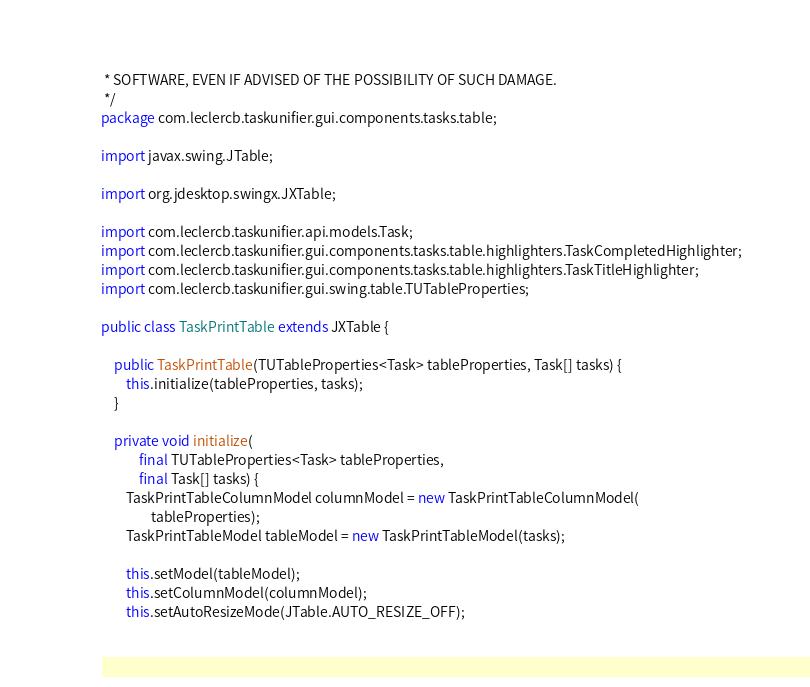<code> <loc_0><loc_0><loc_500><loc_500><_Java_> * SOFTWARE, EVEN IF ADVISED OF THE POSSIBILITY OF SUCH DAMAGE.
 */
package com.leclercb.taskunifier.gui.components.tasks.table;

import javax.swing.JTable;

import org.jdesktop.swingx.JXTable;

import com.leclercb.taskunifier.api.models.Task;
import com.leclercb.taskunifier.gui.components.tasks.table.highlighters.TaskCompletedHighlighter;
import com.leclercb.taskunifier.gui.components.tasks.table.highlighters.TaskTitleHighlighter;
import com.leclercb.taskunifier.gui.swing.table.TUTableProperties;

public class TaskPrintTable extends JXTable {
	
	public TaskPrintTable(TUTableProperties<Task> tableProperties, Task[] tasks) {
		this.initialize(tableProperties, tasks);
	}
	
	private void initialize(
			final TUTableProperties<Task> tableProperties,
			final Task[] tasks) {
		TaskPrintTableColumnModel columnModel = new TaskPrintTableColumnModel(
				tableProperties);
		TaskPrintTableModel tableModel = new TaskPrintTableModel(tasks);
		
		this.setModel(tableModel);
		this.setColumnModel(columnModel);
		this.setAutoResizeMode(JTable.AUTO_RESIZE_OFF);</code> 